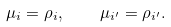Convert formula to latex. <formula><loc_0><loc_0><loc_500><loc_500>\mu _ { i } = \rho _ { i } , \quad \mu _ { i ^ { \prime } } = \rho _ { i ^ { \prime } } .</formula> 